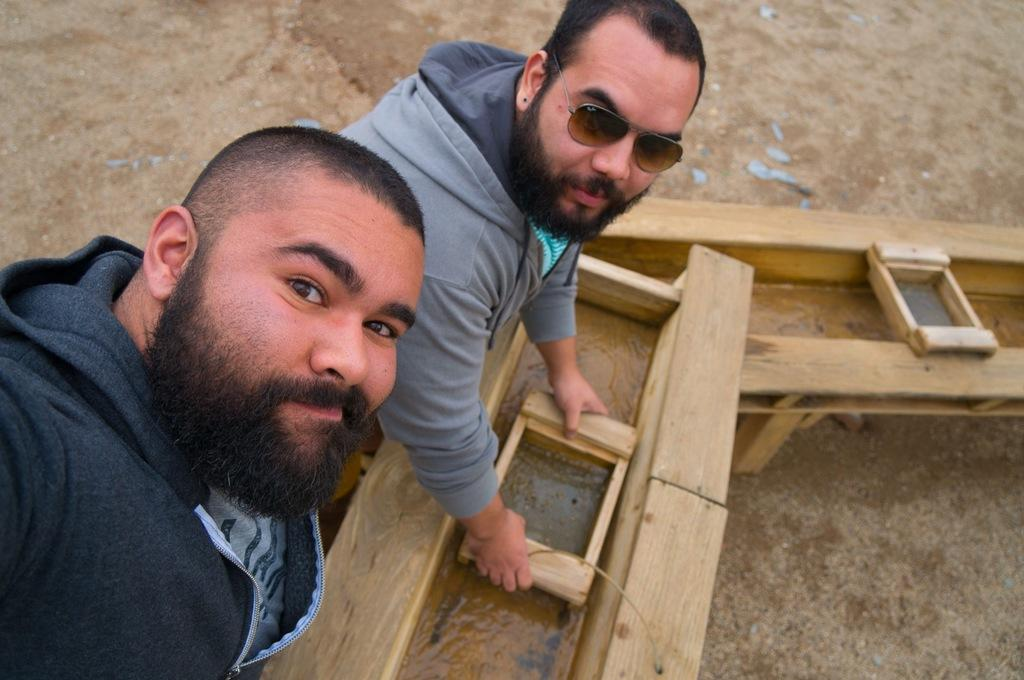How many people are in the image? There are two men in the image. What expressions do the men have? Both men are smiling. What is the man on the left wearing? The man on the left is wearing goggles. What is the man with goggles holding? The man with goggles is holding a wooden object. What can be seen in the background of the image? There is water and the ground visible in the background of the image. What type of dinner is being served in the image? There is no dinner or any food visible in the image. Can you describe the cave where the men are standing in the image? There is no cave present in the image; it features two men standing near water. 